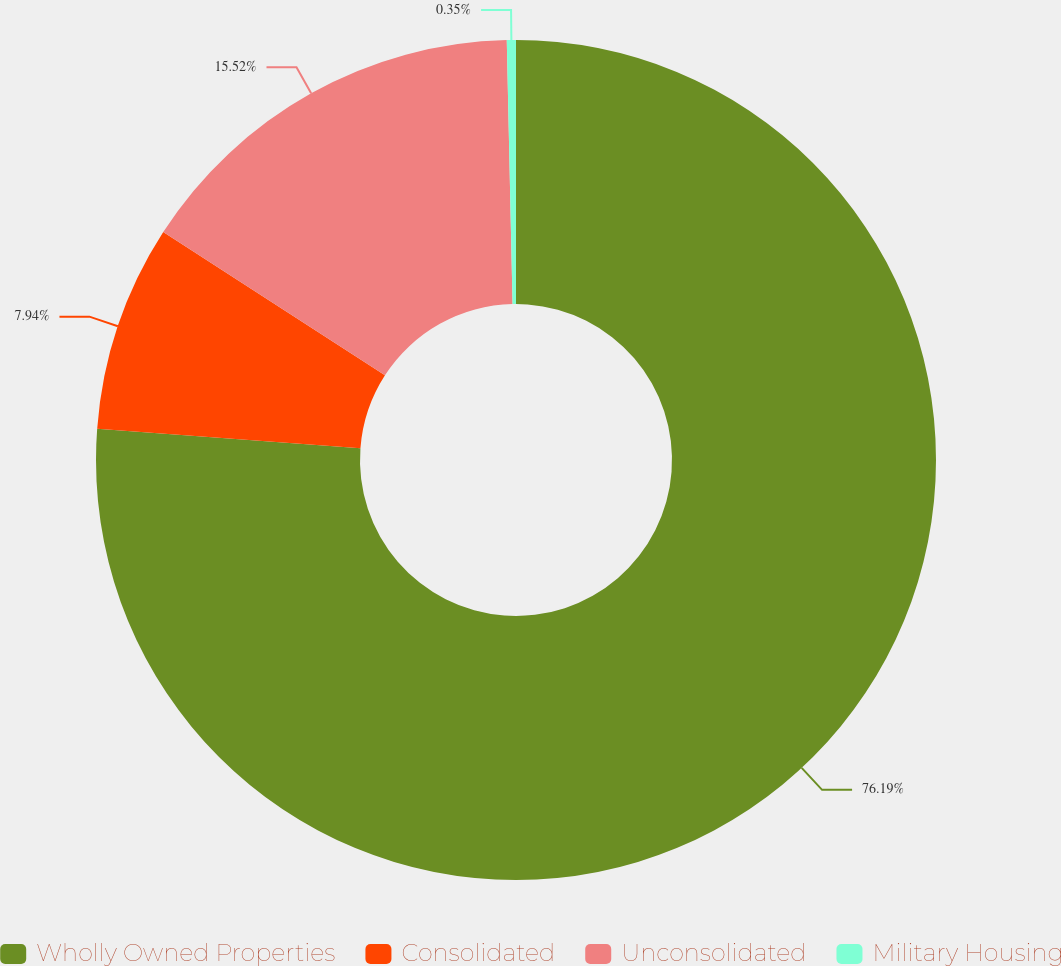Convert chart to OTSL. <chart><loc_0><loc_0><loc_500><loc_500><pie_chart><fcel>Wholly Owned Properties<fcel>Consolidated<fcel>Unconsolidated<fcel>Military Housing<nl><fcel>76.19%<fcel>7.94%<fcel>15.52%<fcel>0.35%<nl></chart> 